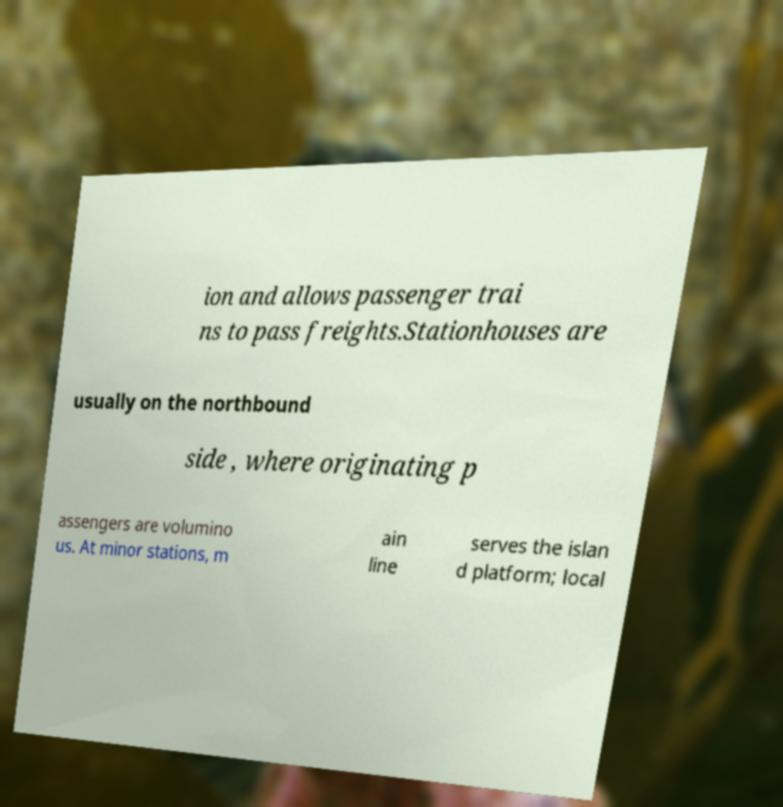Please identify and transcribe the text found in this image. ion and allows passenger trai ns to pass freights.Stationhouses are usually on the northbound side , where originating p assengers are volumino us. At minor stations, m ain line serves the islan d platform; local 